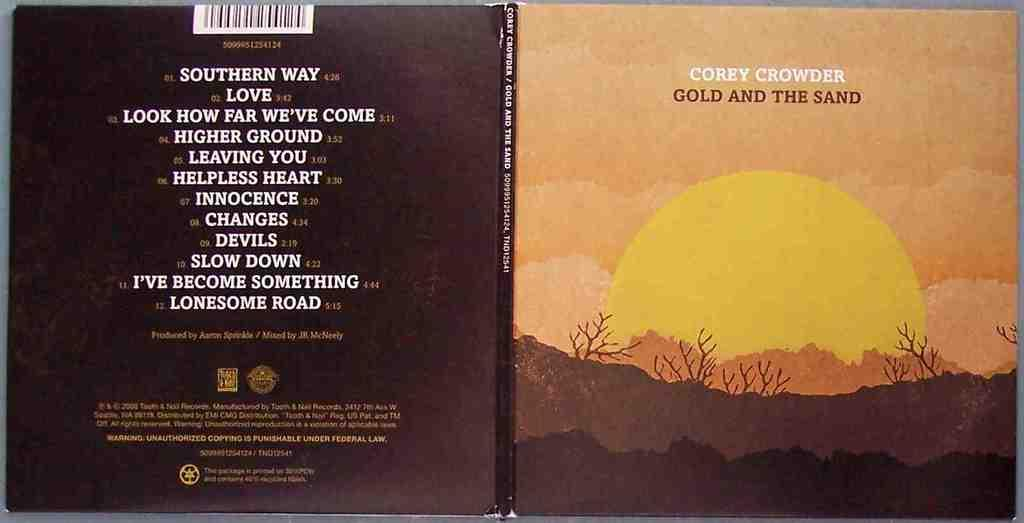Provide a one-sentence caption for the provided image. A cd cover for music by Corey Crowder shows a sunset and song list. 